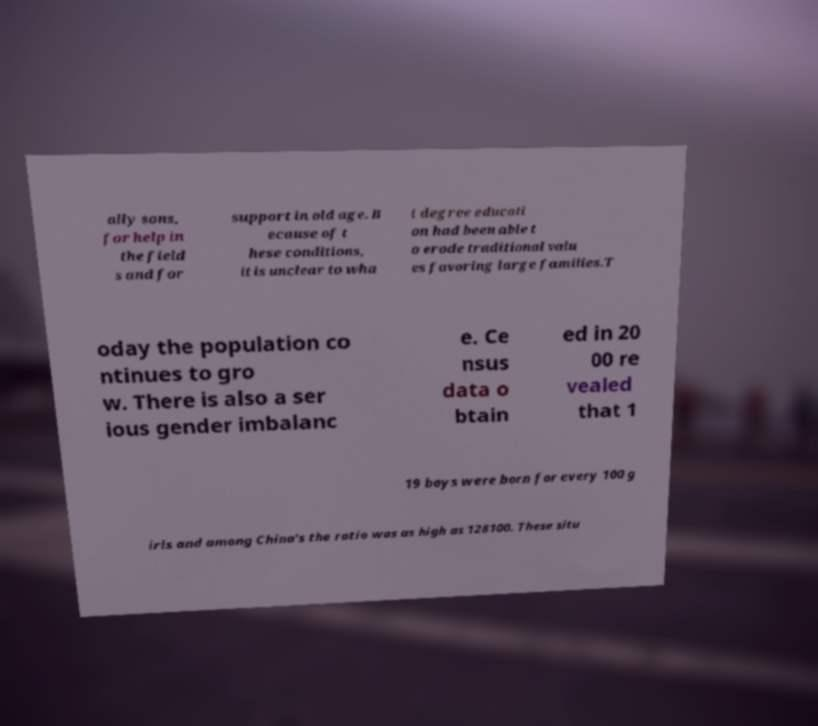Please identify and transcribe the text found in this image. ally sons, for help in the field s and for support in old age. B ecause of t hese conditions, it is unclear to wha t degree educati on had been able t o erode traditional valu es favoring large families.T oday the population co ntinues to gro w. There is also a ser ious gender imbalanc e. Ce nsus data o btain ed in 20 00 re vealed that 1 19 boys were born for every 100 g irls and among China's the ratio was as high as 128100. These situ 